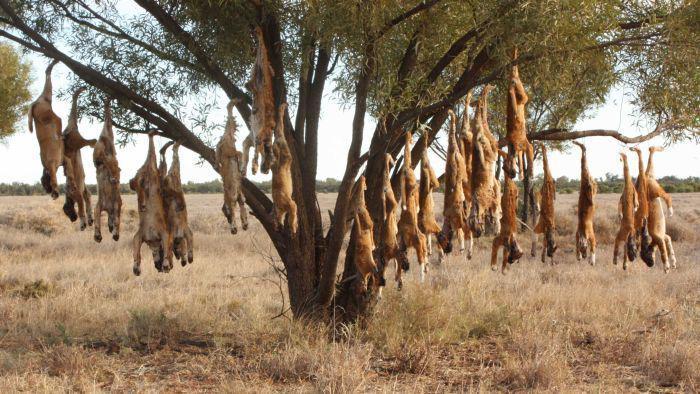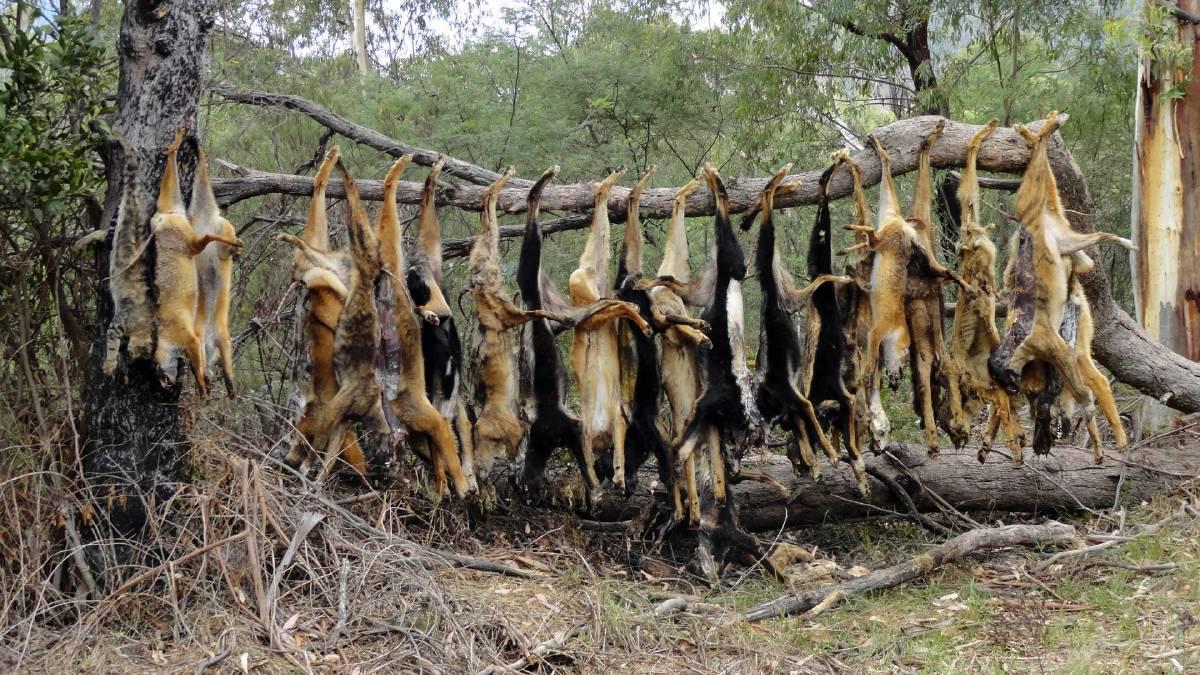The first image is the image on the left, the second image is the image on the right. For the images shown, is this caption "There is one living animal in the image on the right." true? Answer yes or no. No. The first image is the image on the left, the second image is the image on the right. Evaluate the accuracy of this statement regarding the images: "An image shows one dingo standing on the ground.". Is it true? Answer yes or no. No. 